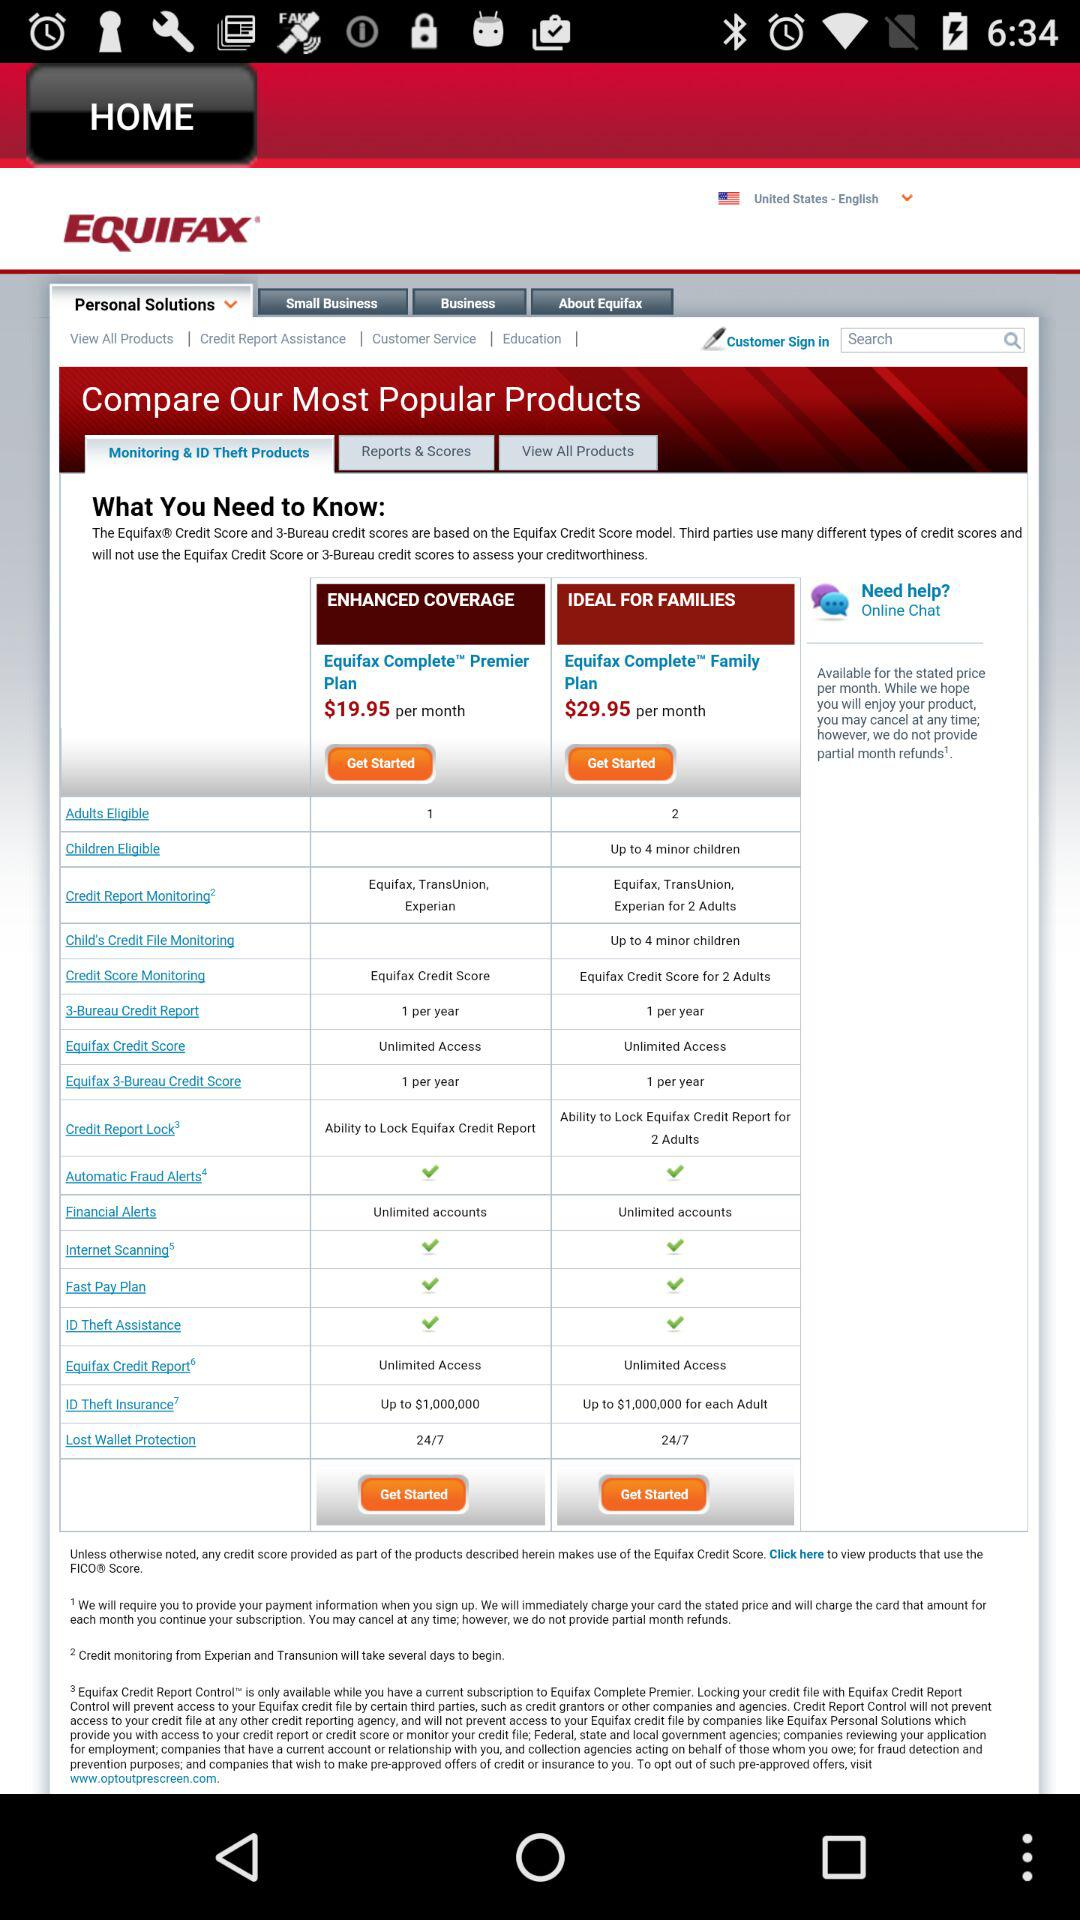What's the price of Equifax complete premier plan? The price is $19.95 per month. 